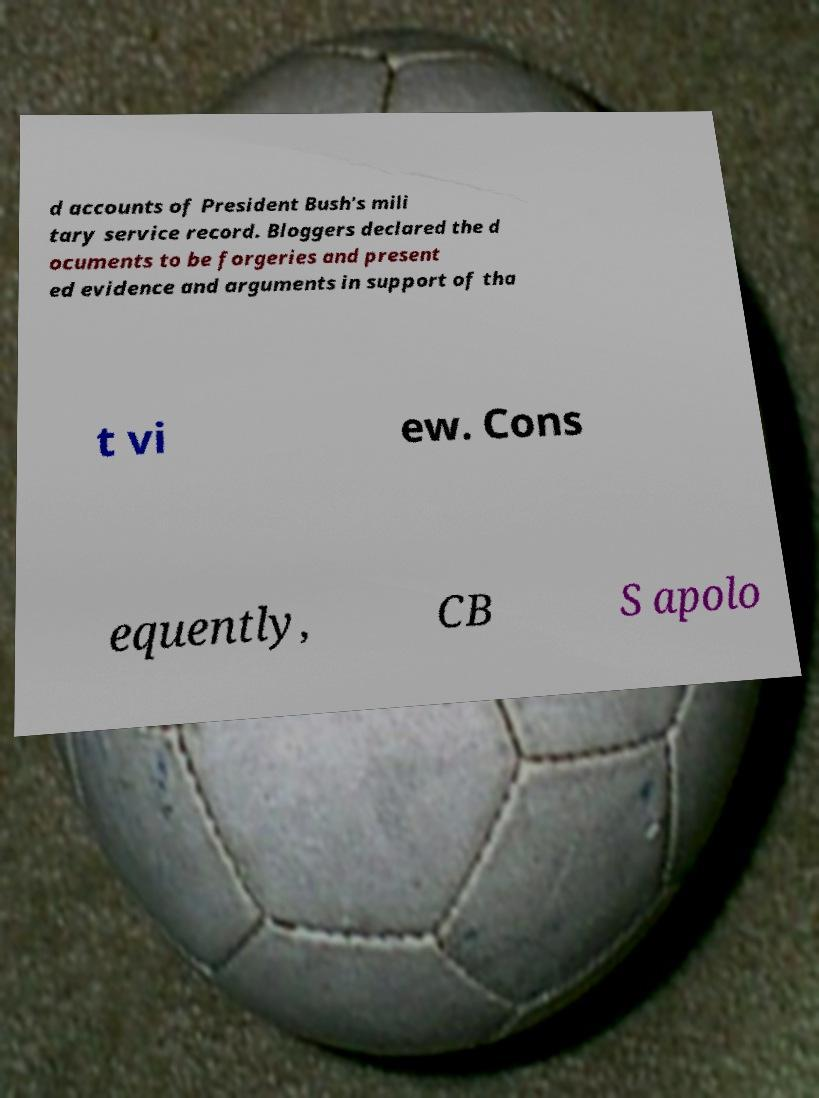Can you accurately transcribe the text from the provided image for me? d accounts of President Bush's mili tary service record. Bloggers declared the d ocuments to be forgeries and present ed evidence and arguments in support of tha t vi ew. Cons equently, CB S apolo 